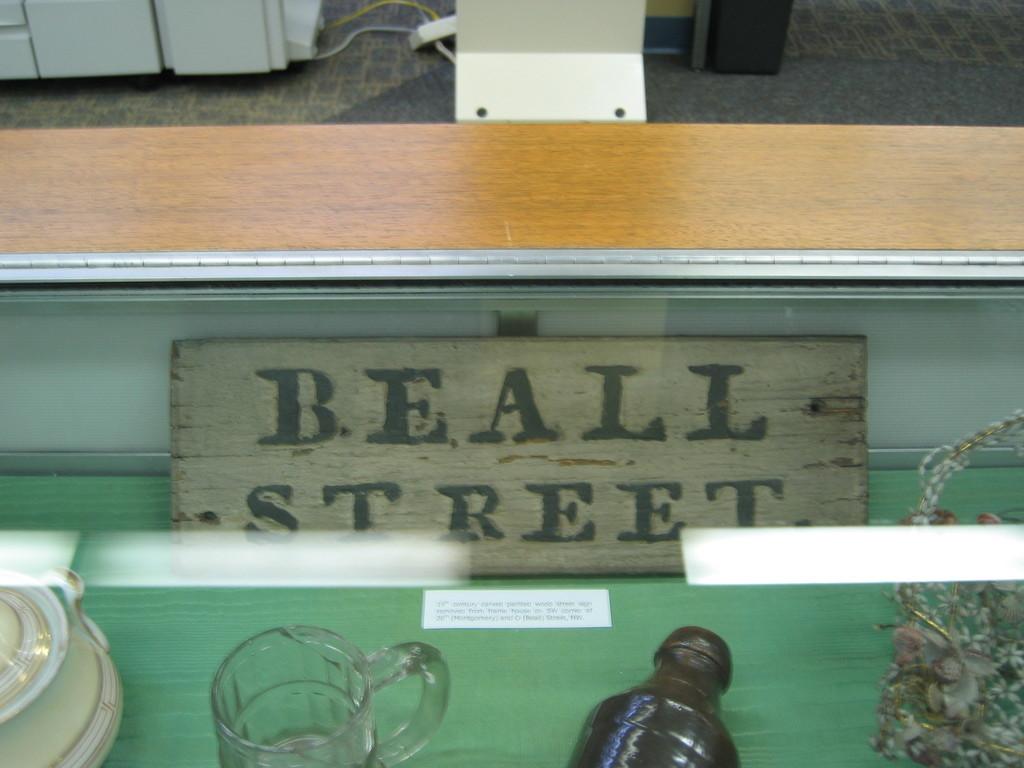What street is it?
Your answer should be compact. Beall. 